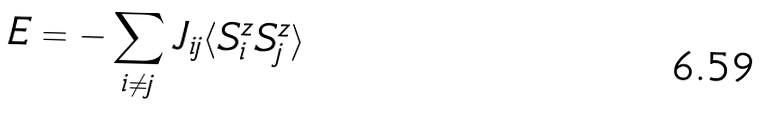<formula> <loc_0><loc_0><loc_500><loc_500>E = - \sum _ { i \neq j } J _ { i j } \langle S _ { i } ^ { z } S _ { j } ^ { z } \rangle</formula> 